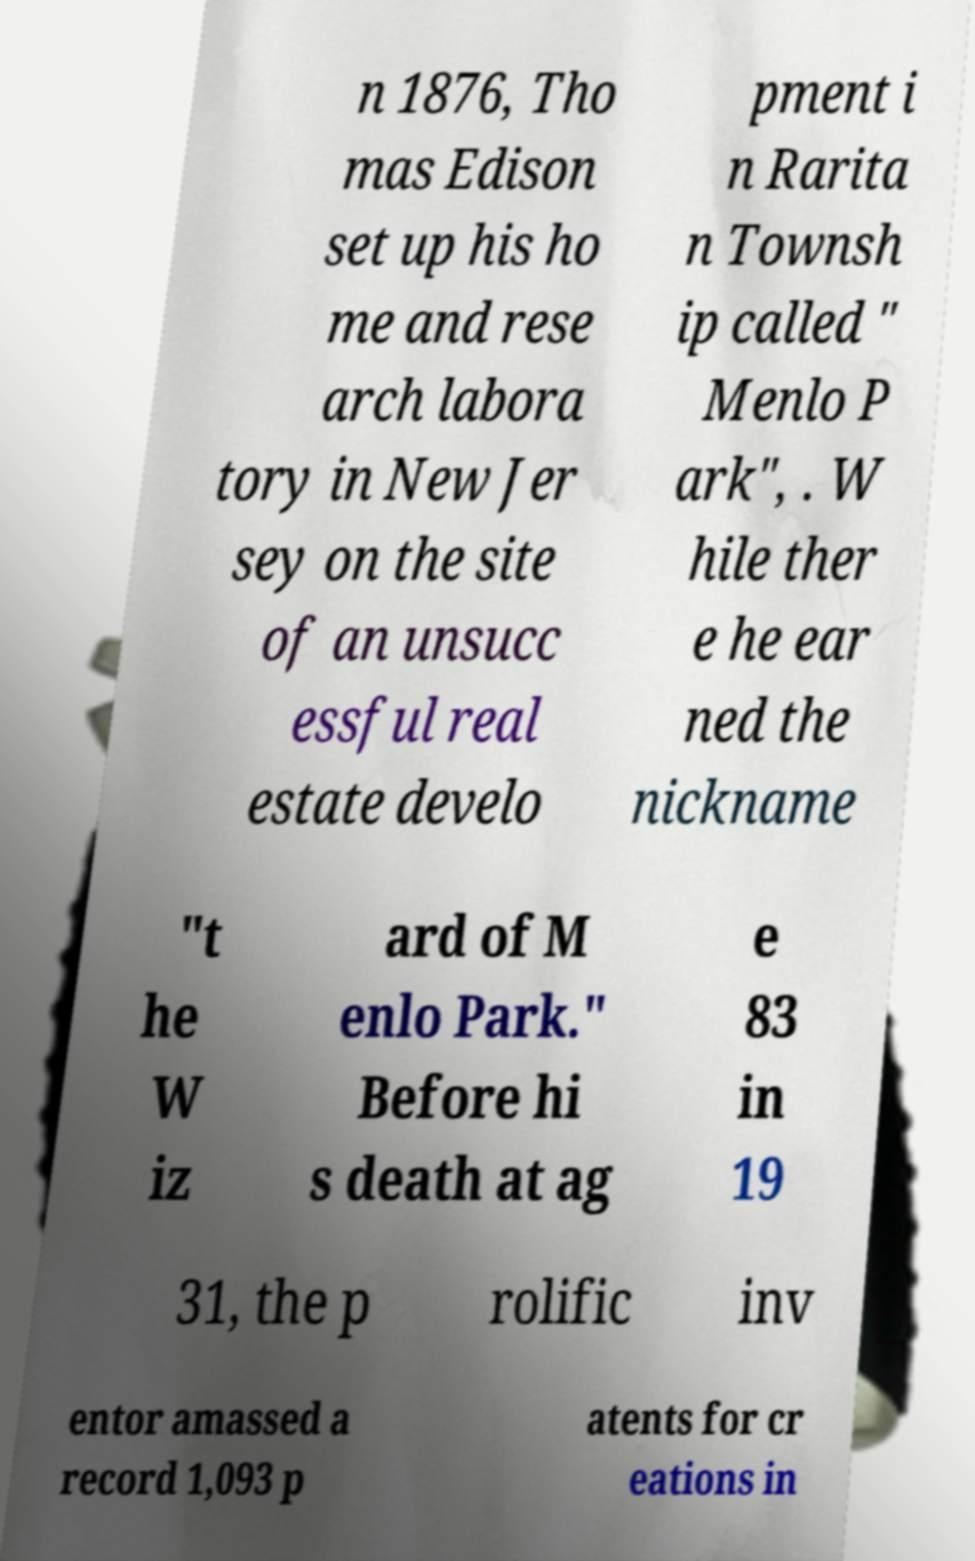What messages or text are displayed in this image? I need them in a readable, typed format. n 1876, Tho mas Edison set up his ho me and rese arch labora tory in New Jer sey on the site of an unsucc essful real estate develo pment i n Rarita n Townsh ip called " Menlo P ark", . W hile ther e he ear ned the nickname "t he W iz ard of M enlo Park." Before hi s death at ag e 83 in 19 31, the p rolific inv entor amassed a record 1,093 p atents for cr eations in 